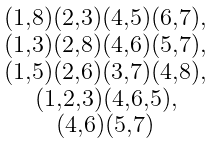Convert formula to latex. <formula><loc_0><loc_0><loc_500><loc_500>\begin{smallmatrix} ( 1 , 8 ) ( 2 , 3 ) ( 4 , 5 ) ( 6 , 7 ) , \\ ( 1 , 3 ) ( 2 , 8 ) ( 4 , 6 ) ( 5 , 7 ) , \\ ( 1 , 5 ) ( 2 , 6 ) ( 3 , 7 ) ( 4 , 8 ) , \\ ( 1 , 2 , 3 ) ( 4 , 6 , 5 ) , \\ ( 4 , 6 ) ( 5 , 7 ) \end{smallmatrix}</formula> 